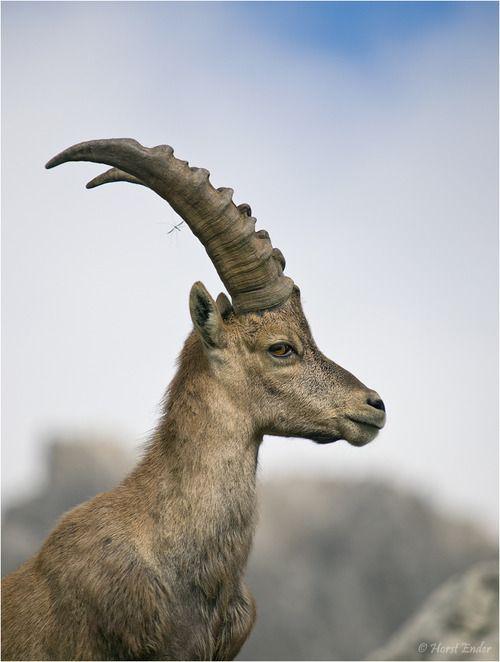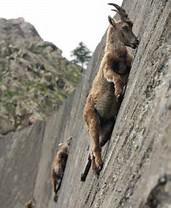The first image is the image on the left, the second image is the image on the right. For the images displayed, is the sentence "The left and right image contains the same number of goats." factually correct? Answer yes or no. No. The first image is the image on the left, the second image is the image on the right. For the images shown, is this caption "One image contains one horned animal with its head in profile facing right, and the other image includes two hooved animals." true? Answer yes or no. Yes. 